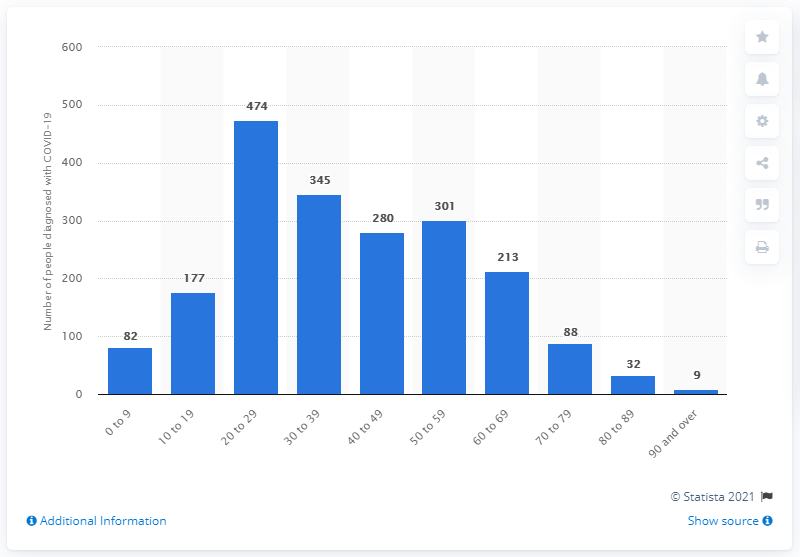Mention a couple of crucial points in this snapshot. On November 16, 2020, a total of 474 individuals in New Zealand were diagnosed with COVID-19. 